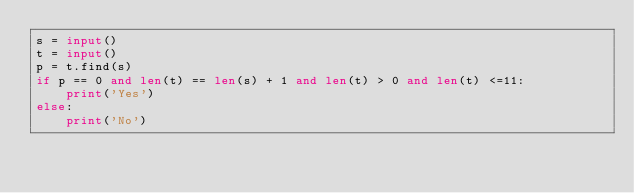<code> <loc_0><loc_0><loc_500><loc_500><_Python_>s = input()
t = input()
p = t.find(s)
if p == 0 and len(t) == len(s) + 1 and len(t) > 0 and len(t) <=11:
    print('Yes')
else:
    print('No')</code> 